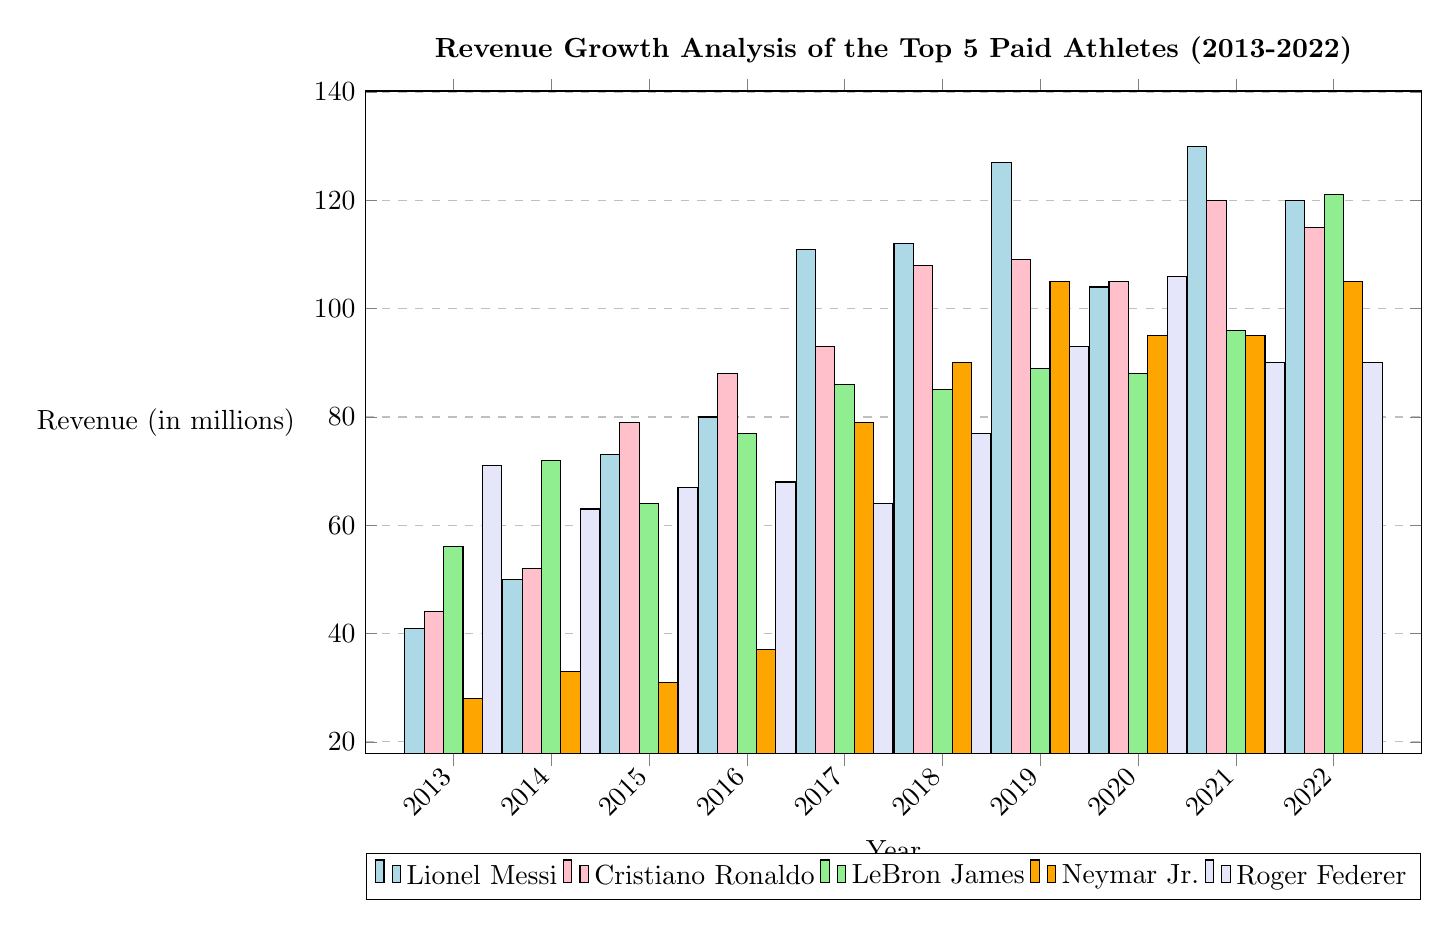What was Lionel Messi's revenue in 2016? Referring to the bar corresponding to the year 2016 in Lionel Messi's section of the diagram, the revenue value is indicated at the height of the bar, which is 80 million.
Answer: 80 million Which athlete had the highest revenue in 2017? By comparing the heights of all bars for the year 2017, Lionel Messi's bar reaches the highest point at 111 million, making him the athlete with the highest revenue for that year.
Answer: Lionel Messi Did Roger Federer experience a revenue increase or decrease from 2015 to 2016? Analyzing the heights of Roger Federer’s bars for 2015 (67 million) and 2016 (68 million), it is clear that his revenue increased as indicated by the bar heights moving from 67 to 68 million.
Answer: Increase What is the total revenue for Neymar Jr. over the years 2013 to 2022? Adding the values represented by Neymar Jr.'s bars from 2013 (28), 2014 (33), 2015 (31), 2016 (37), 2017 (79), 2018 (90), 2019 (105), 2020 (95), 2021 (95), and 2022 (105) results in a cumulative total of 28 + 33 + 31 + 37 + 79 + 90 + 105 + 95 + 95 + 105 = 798 million.
Answer: 798 million What was the revenue of LeBron James in 2022? Checking the height of the bar for LeBron James for the year 2022, the bar reaches a height that corresponds to a revenue of 121 million.
Answer: 121 million Which athlete had the lowest revenue in 2014? By observing all the revenue bars for the year 2014, Neymar Jr. has the lowest bar height at 33 million, which is the lowest among all athletes in that year.
Answer: Neymar Jr 